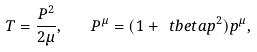<formula> <loc_0><loc_0><loc_500><loc_500>T = \frac { P ^ { 2 } } { 2 \mu } , \quad P ^ { \mu } = ( 1 + \ t b e t a p ^ { 2 } ) p ^ { \mu } ,</formula> 